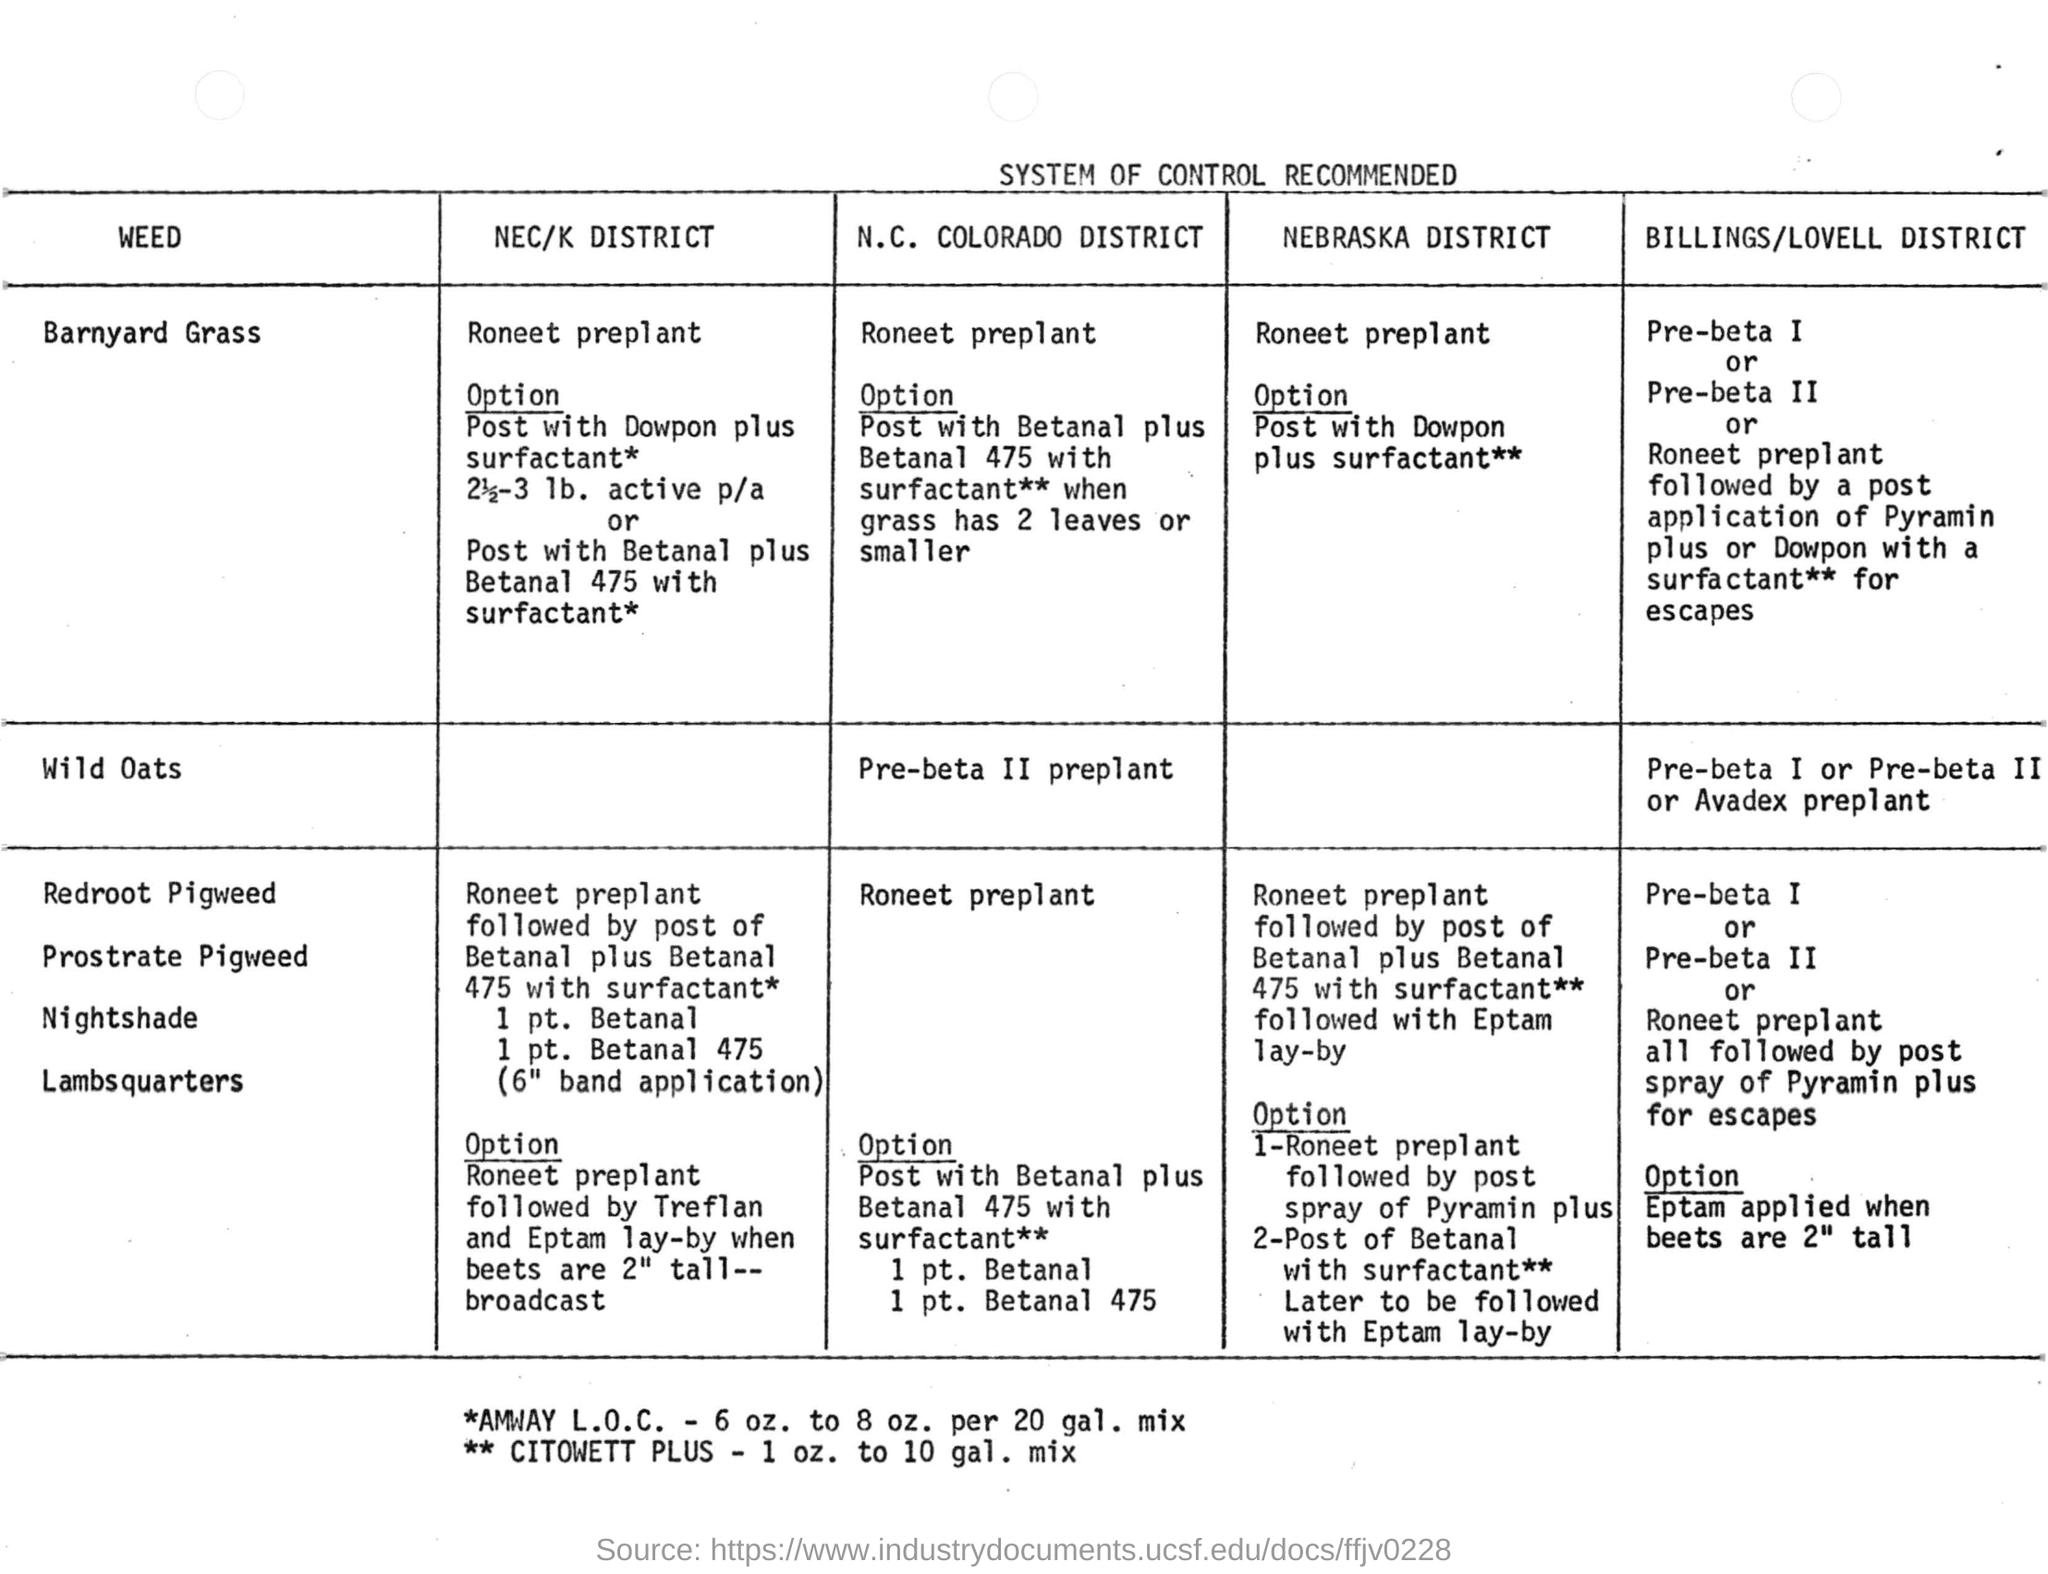List a handful of essential elements in this visual. The heading for the document is, "A system of control is recommended. According to the North Carolina Colorado district, the recommended option for controlling barnyard grass weeds is to apply Betanal plus Betanal 475 with surfactant when the grass has two leaves or smaller. 